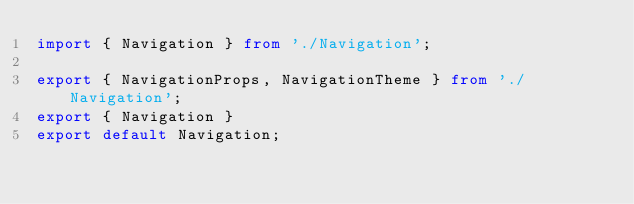<code> <loc_0><loc_0><loc_500><loc_500><_TypeScript_>import { Navigation } from './Navigation';

export { NavigationProps, NavigationTheme } from './Navigation';
export { Navigation }
export default Navigation;
</code> 